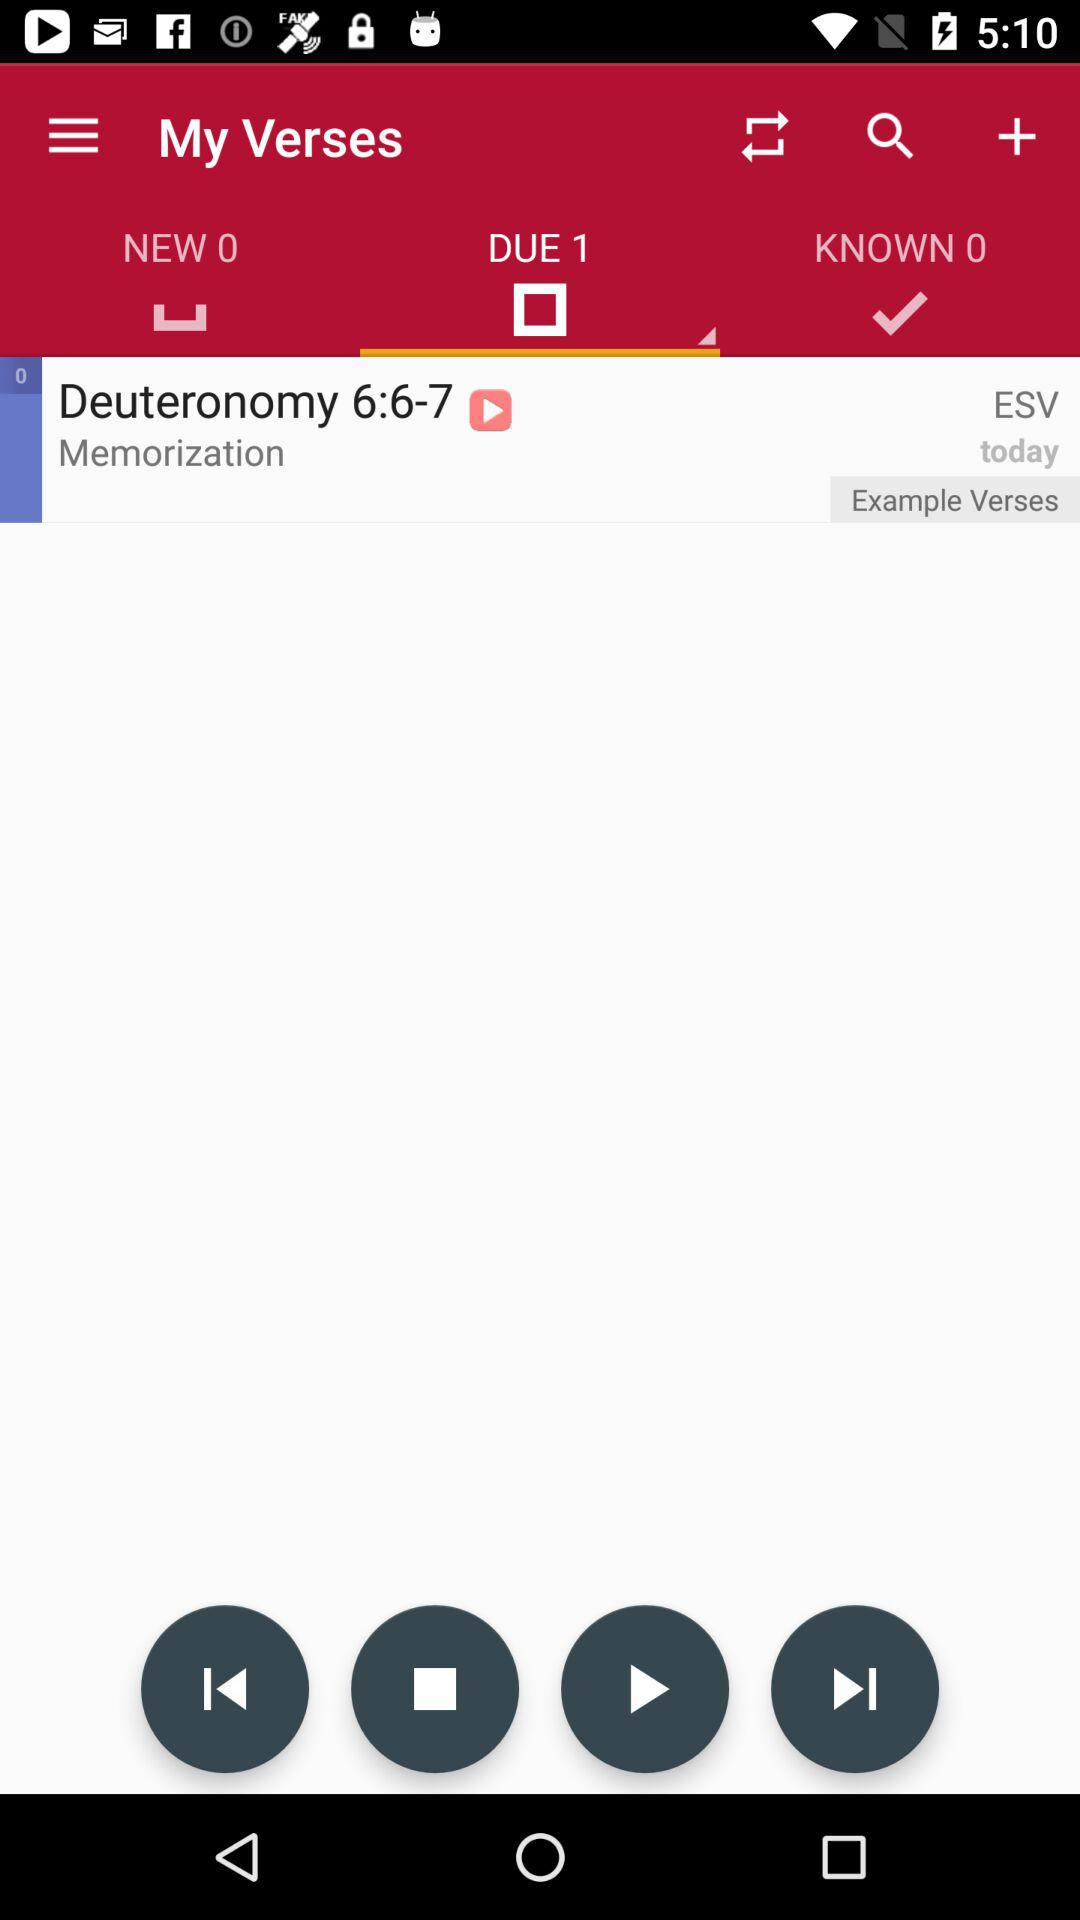Which tab is selected? The selected tab is "DUE 1". 